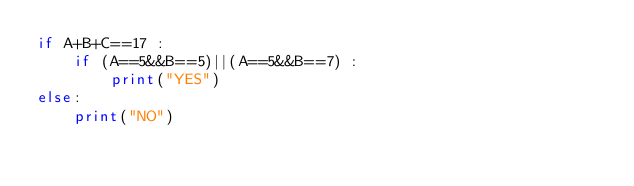<code> <loc_0><loc_0><loc_500><loc_500><_Python_>if A+B+C==17 :
    if (A==5&&B==5)||(A==5&&B==7) :
        print("YES")
else:
    print("NO")</code> 